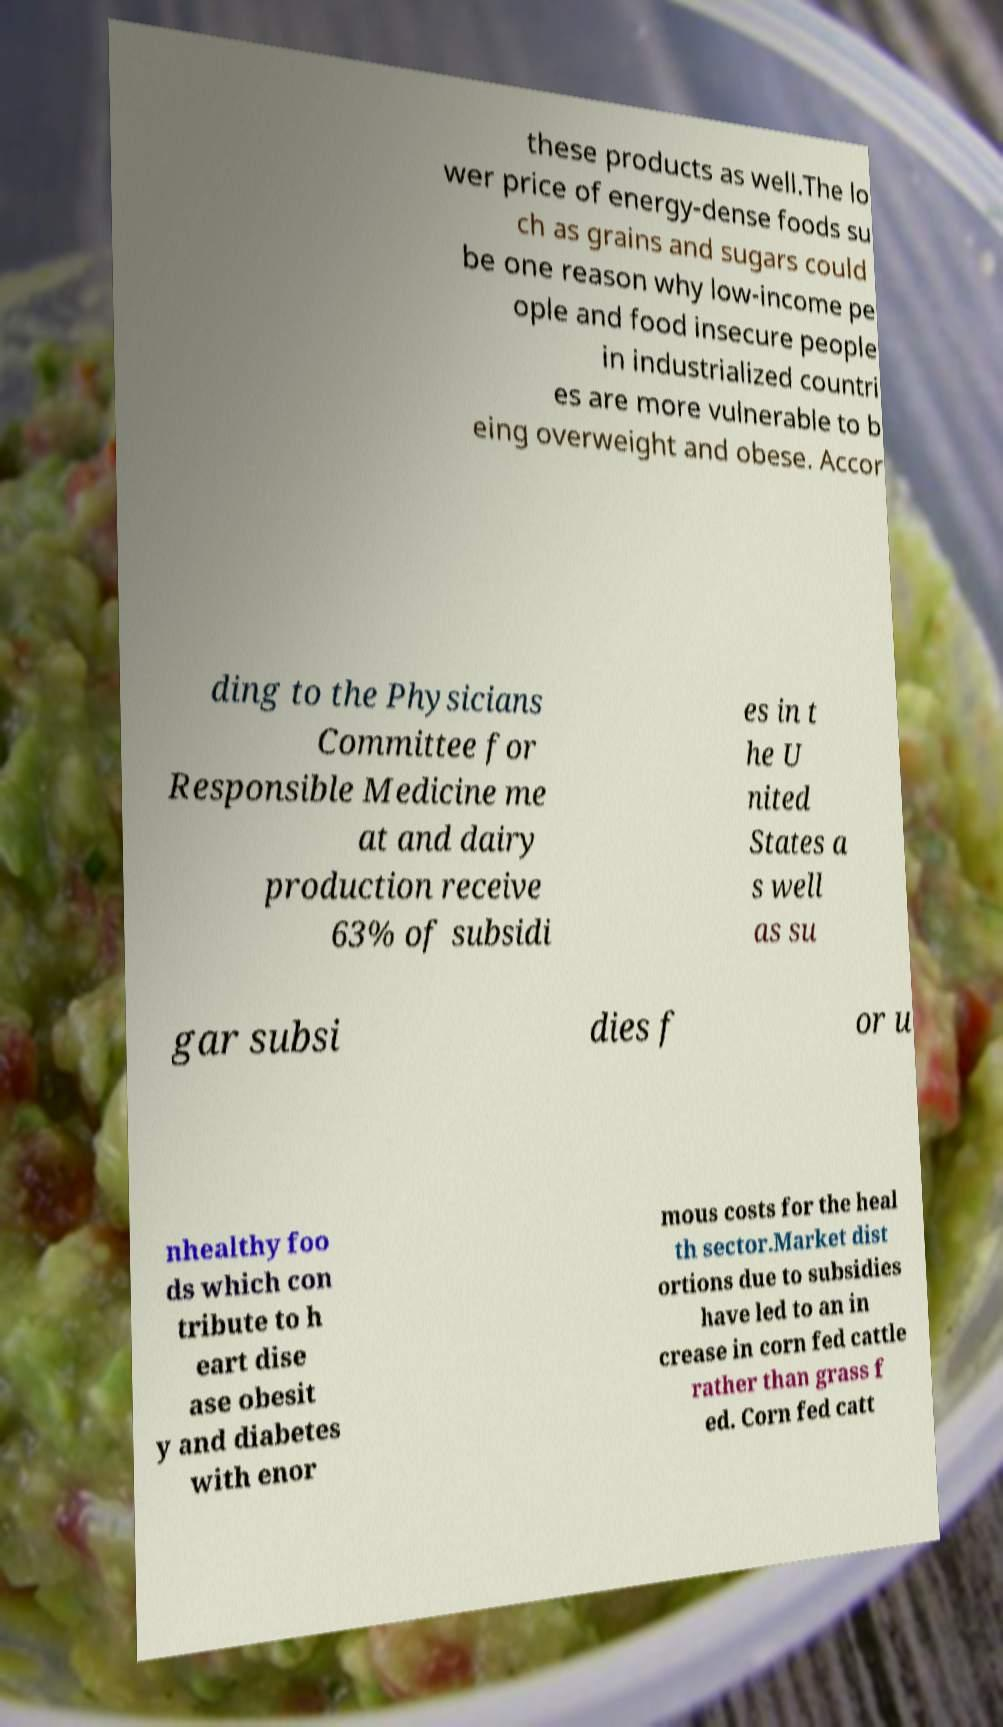Can you accurately transcribe the text from the provided image for me? these products as well.The lo wer price of energy-dense foods su ch as grains and sugars could be one reason why low-income pe ople and food insecure people in industrialized countri es are more vulnerable to b eing overweight and obese. Accor ding to the Physicians Committee for Responsible Medicine me at and dairy production receive 63% of subsidi es in t he U nited States a s well as su gar subsi dies f or u nhealthy foo ds which con tribute to h eart dise ase obesit y and diabetes with enor mous costs for the heal th sector.Market dist ortions due to subsidies have led to an in crease in corn fed cattle rather than grass f ed. Corn fed catt 